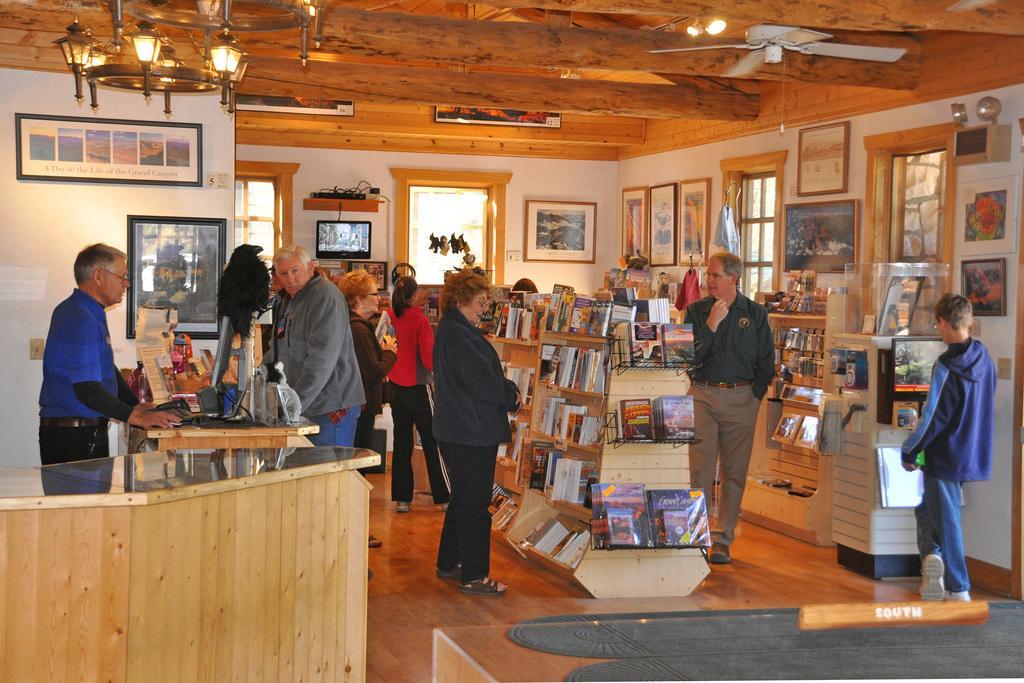Describe this image in one or two sentences. There are groups of people standing. These are the photo frames, which are attached to the walls. I think this is a bookstore. These are the books, which are arranged in the racks. I think this is a television, which is fixed to the wall. These are the windows. This is a table with a computer, mouse and few other things on it. I can see the lamps and a ceiling fan, which are attached to the ceiling. This is a floor. 